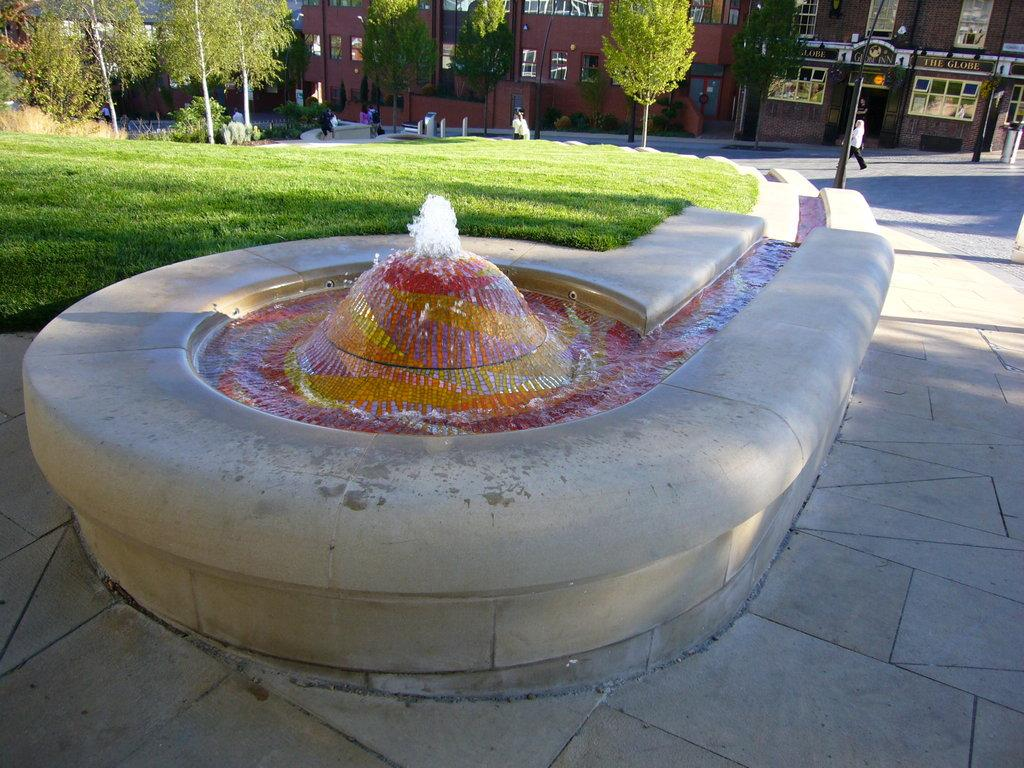What is the main feature in the image? There is a water fountain in the image. What else can be seen in the background of the image? There are buildings, trees, and grass visible in the image. Are there any structures or objects in the image? Yes, poles and windows are present in the image. What is happening in the image? There are people walking on the road in the image. What type of nail is being used to hold the brick in place in the image? There is no nail or brick present in the image; it features a water fountain, buildings, trees, grass, poles, windows, and people walking on the road. What is the whip used for in the image? There is no whip present in the image. 